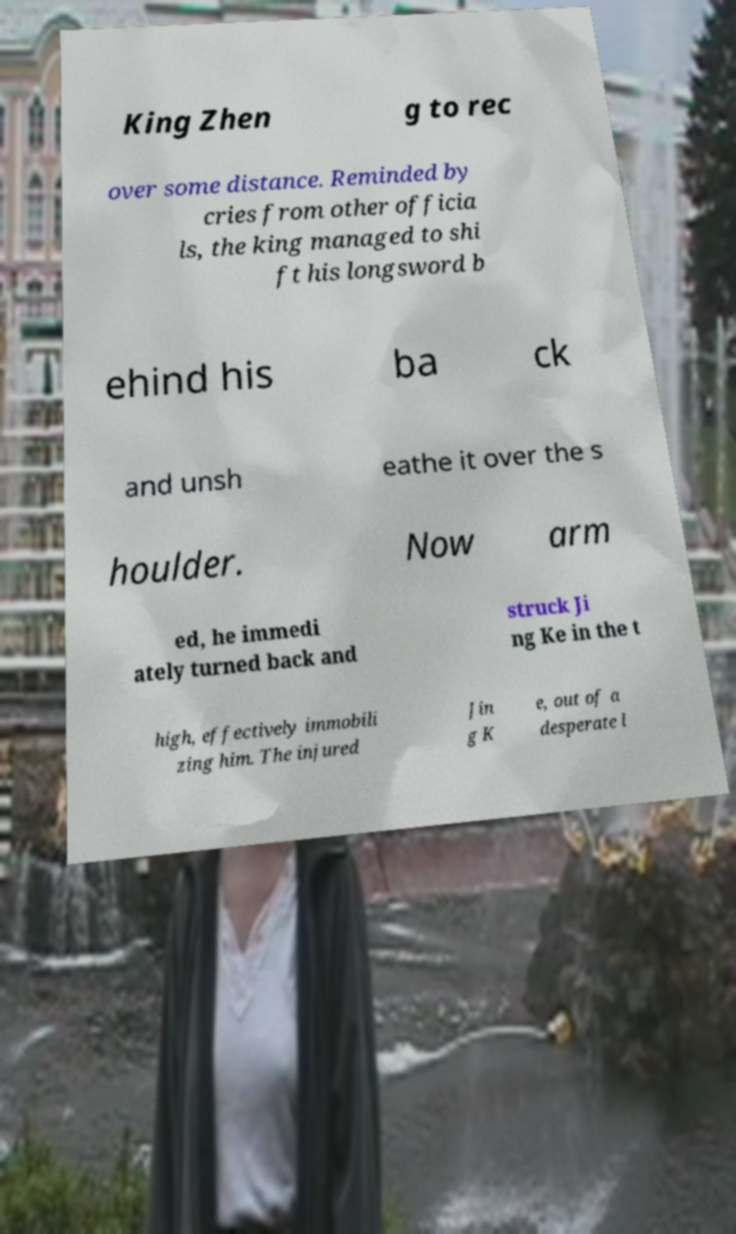I need the written content from this picture converted into text. Can you do that? King Zhen g to rec over some distance. Reminded by cries from other officia ls, the king managed to shi ft his longsword b ehind his ba ck and unsh eathe it over the s houlder. Now arm ed, he immedi ately turned back and struck Ji ng Ke in the t high, effectively immobili zing him. The injured Jin g K e, out of a desperate l 